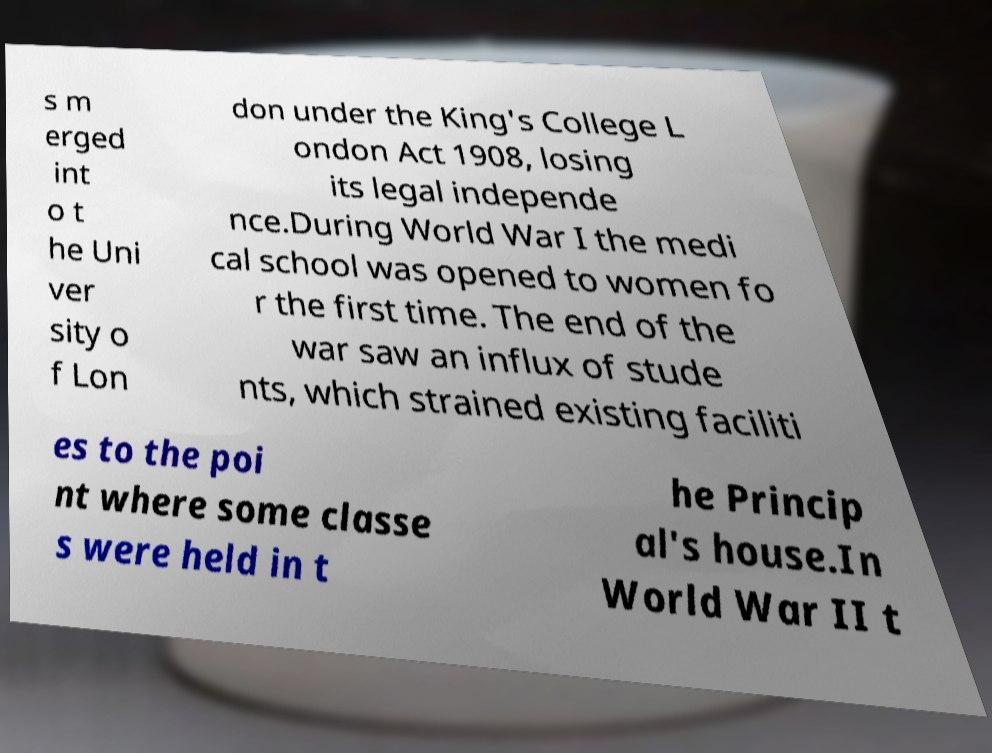Can you accurately transcribe the text from the provided image for me? s m erged int o t he Uni ver sity o f Lon don under the King's College L ondon Act 1908, losing its legal independe nce.During World War I the medi cal school was opened to women fo r the first time. The end of the war saw an influx of stude nts, which strained existing faciliti es to the poi nt where some classe s were held in t he Princip al's house.In World War II t 